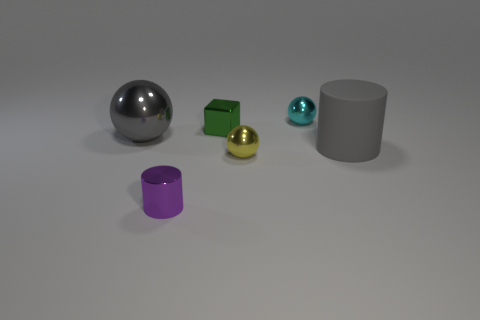Which of these objects reflect light the most? The spherical object reflects light the most. Its polished, mirrored surface creates clear reflections, giving it a glossy appearance compared to the others. 